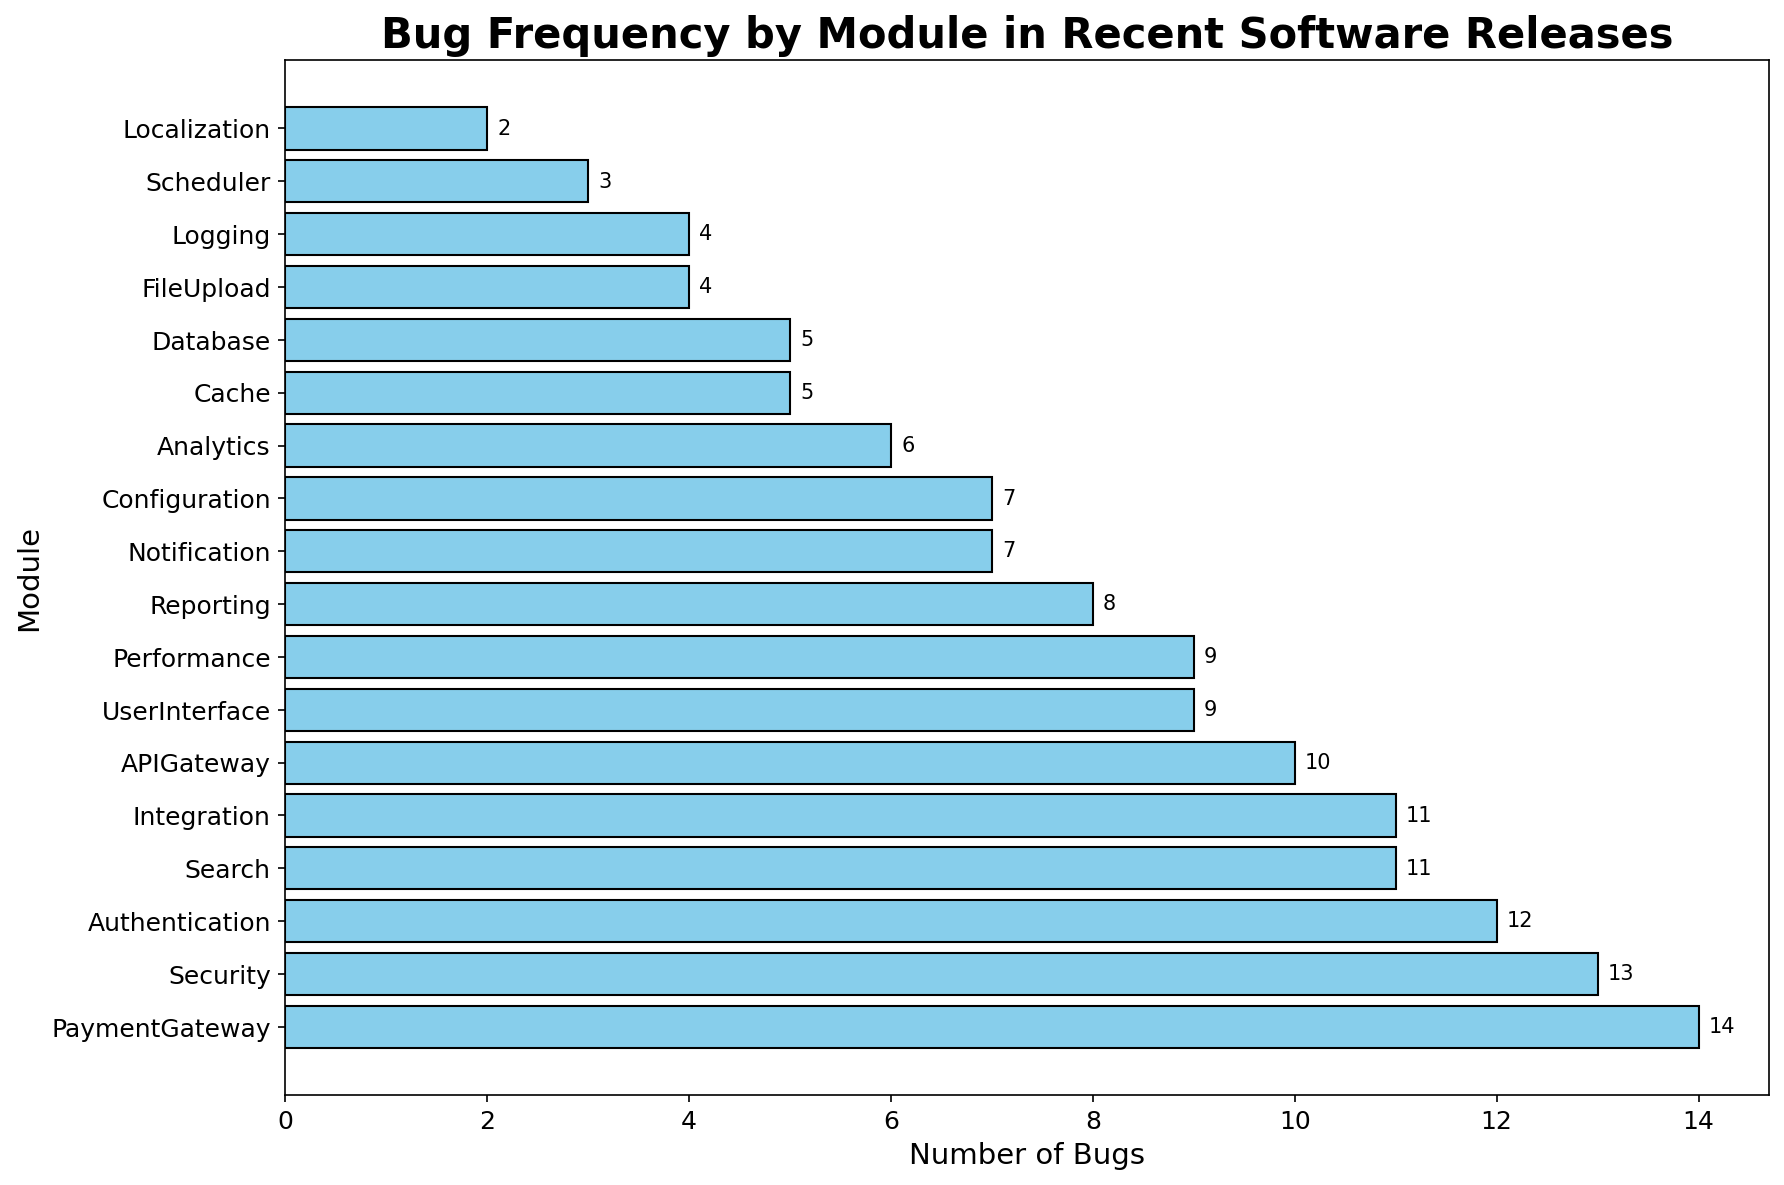What module has the highest number of bugs? The "PaymentGateway" module has the highest bar in the histogram, indicating it holds the most bugs.
Answer: PaymentGateway Which module has fewer bugs: "UserInterface" or "Analytics"? Compare the lengths of the bars for "UserInterface" and "Analytics". "UserInterface" has 9 bugs and "Analytics" has 6 bugs.
Answer: Analytics What is the total number of bugs in the "Security" and "Performance" modules combined? Add the number of bugs in both modules: Security (13) + Performance (9) = 22
Answer: 22 Which two modules have an equal number of bugs? Look for bars of equal length. "Database" and "Cache" both have 5 bugs.
Answer: Database and Cache Which module has the lowest number of bugs? The "Localization" module has the shortest bar in the histogram, which represents 2 bugs.
Answer: Localization How many modules have more than 10 bugs? Count the bars with a length greater than 10 bugs: Authentication (12), PaymentGateway (14), Search (11), Security (13), and Integration (11) are the modules, making a total of 5.
Answer: 5 What is the difference in the number of bugs between "APIGateway" and "FileUpload"? Subtract the number of bugs in "FileUpload" from "APIGateway": 10 (APIGateway) - 4 (FileUpload) = 6
Answer: 6 Which two modules have the closest number of bugs? Compare the bars to find those with the closest lengths. "UserInterface" and "Performance" have 9 bugs each.
Answer: UserInterface and Performance What is the average number of bugs in "Reporting", "Scheduler", "Localization", and "Cache"? Calculate the average: (8 (Reporting) + 3 (Scheduler) + 2 (Localization) + 5 (Cache)) / 4 = 18 / 4 = 4.5
Answer: 4.5 Which module has more bugs: "Notification" or "Configuration"? Compare the lengths of the bars for "Notification" and "Configuration". "Notification" has 7 bugs, and "Configuration" also has 7 bugs.
Answer: Equal 